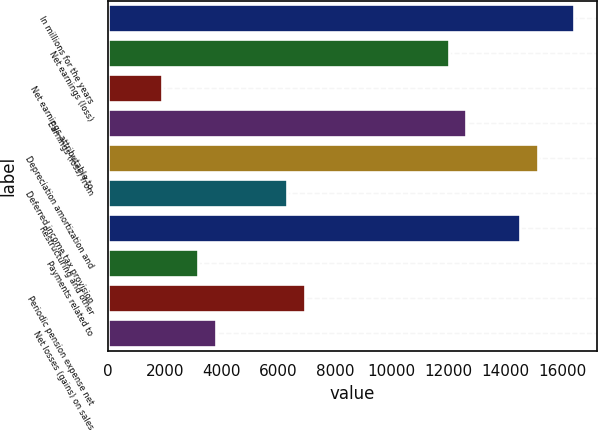Convert chart to OTSL. <chart><loc_0><loc_0><loc_500><loc_500><bar_chart><fcel>In millions for the years<fcel>Net earnings (loss)<fcel>Net earnings attributable to<fcel>Earnings (loss) from<fcel>Depreciation amortization and<fcel>Deferred income tax provision<fcel>Restructuring and other<fcel>Payments related to<fcel>Periodic pension expense net<fcel>Net losses (gains) on sales<nl><fcel>16414<fcel>11997<fcel>1901<fcel>12628<fcel>15152<fcel>6318<fcel>14521<fcel>3163<fcel>6949<fcel>3794<nl></chart> 